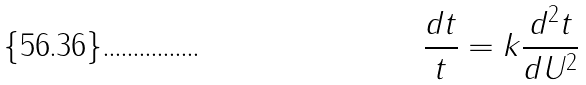Convert formula to latex. <formula><loc_0><loc_0><loc_500><loc_500>\frac { d t } { t } = k \frac { d ^ { 2 } t } { d U ^ { 2 } }</formula> 